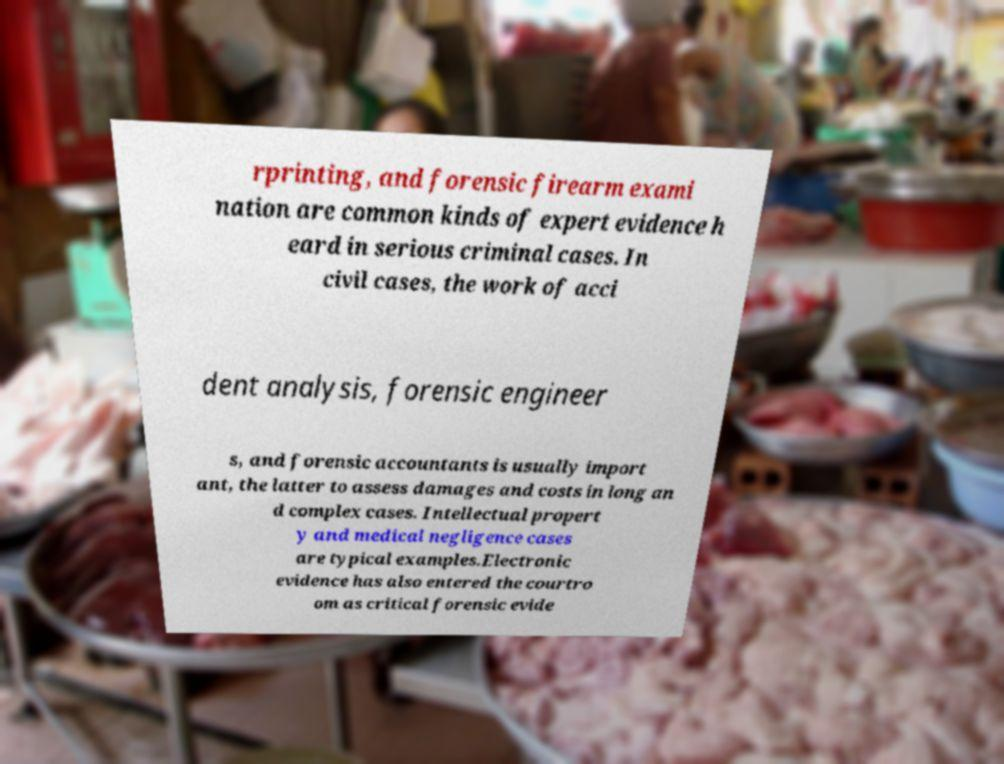There's text embedded in this image that I need extracted. Can you transcribe it verbatim? rprinting, and forensic firearm exami nation are common kinds of expert evidence h eard in serious criminal cases. In civil cases, the work of acci dent analysis, forensic engineer s, and forensic accountants is usually import ant, the latter to assess damages and costs in long an d complex cases. Intellectual propert y and medical negligence cases are typical examples.Electronic evidence has also entered the courtro om as critical forensic evide 